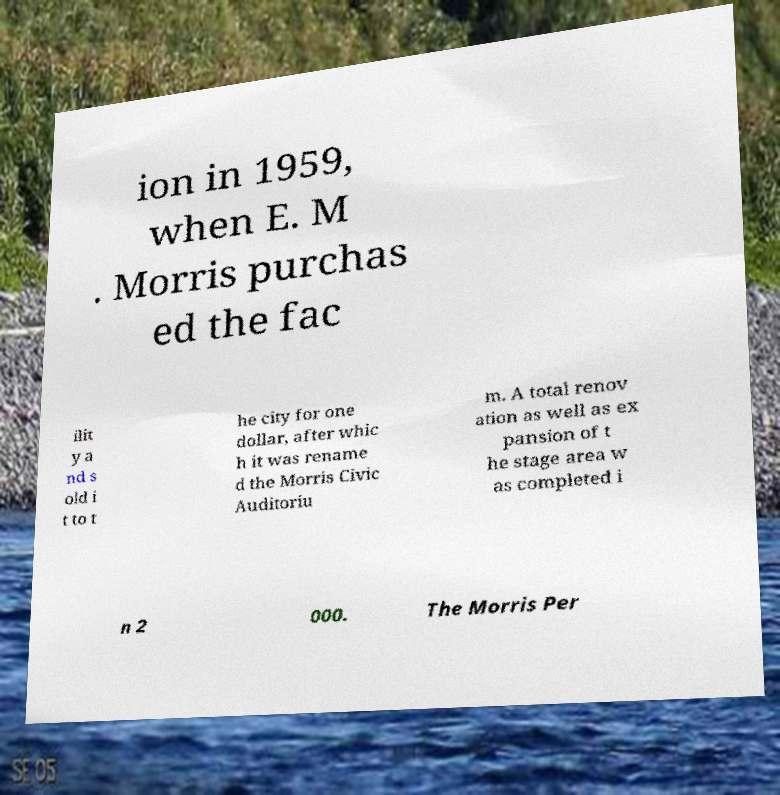I need the written content from this picture converted into text. Can you do that? ion in 1959, when E. M . Morris purchas ed the fac ilit y a nd s old i t to t he city for one dollar, after whic h it was rename d the Morris Civic Auditoriu m. A total renov ation as well as ex pansion of t he stage area w as completed i n 2 000. The Morris Per 